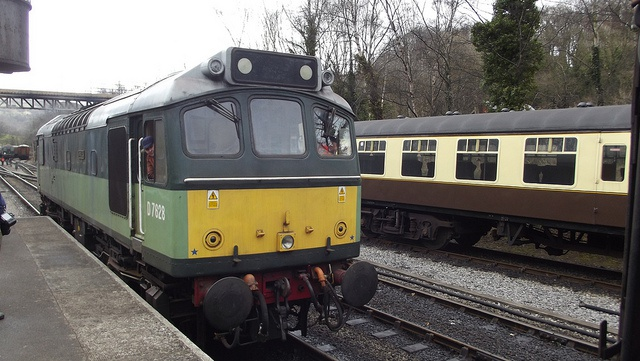Describe the objects in this image and their specific colors. I can see train in gray, black, darkgray, and tan tones, train in gray, black, and beige tones, people in gray, maroon, and black tones, people in gray, black, and navy tones, and cell phone in gray, black, lightgray, and darkgray tones in this image. 